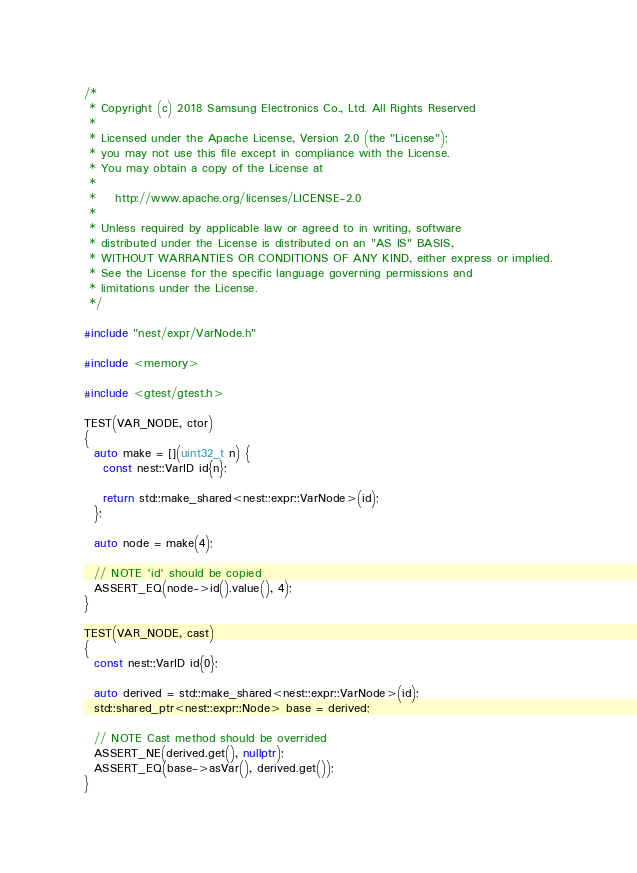<code> <loc_0><loc_0><loc_500><loc_500><_C++_>/*
 * Copyright (c) 2018 Samsung Electronics Co., Ltd. All Rights Reserved
 *
 * Licensed under the Apache License, Version 2.0 (the "License");
 * you may not use this file except in compliance with the License.
 * You may obtain a copy of the License at
 *
 *    http://www.apache.org/licenses/LICENSE-2.0
 *
 * Unless required by applicable law or agreed to in writing, software
 * distributed under the License is distributed on an "AS IS" BASIS,
 * WITHOUT WARRANTIES OR CONDITIONS OF ANY KIND, either express or implied.
 * See the License for the specific language governing permissions and
 * limitations under the License.
 */

#include "nest/expr/VarNode.h"

#include <memory>

#include <gtest/gtest.h>

TEST(VAR_NODE, ctor)
{
  auto make = [](uint32_t n) {
    const nest::VarID id{n};

    return std::make_shared<nest::expr::VarNode>(id);
  };

  auto node = make(4);

  // NOTE 'id' should be copied
  ASSERT_EQ(node->id().value(), 4);
}

TEST(VAR_NODE, cast)
{
  const nest::VarID id{0};

  auto derived = std::make_shared<nest::expr::VarNode>(id);
  std::shared_ptr<nest::expr::Node> base = derived;

  // NOTE Cast method should be overrided
  ASSERT_NE(derived.get(), nullptr);
  ASSERT_EQ(base->asVar(), derived.get());
}
</code> 